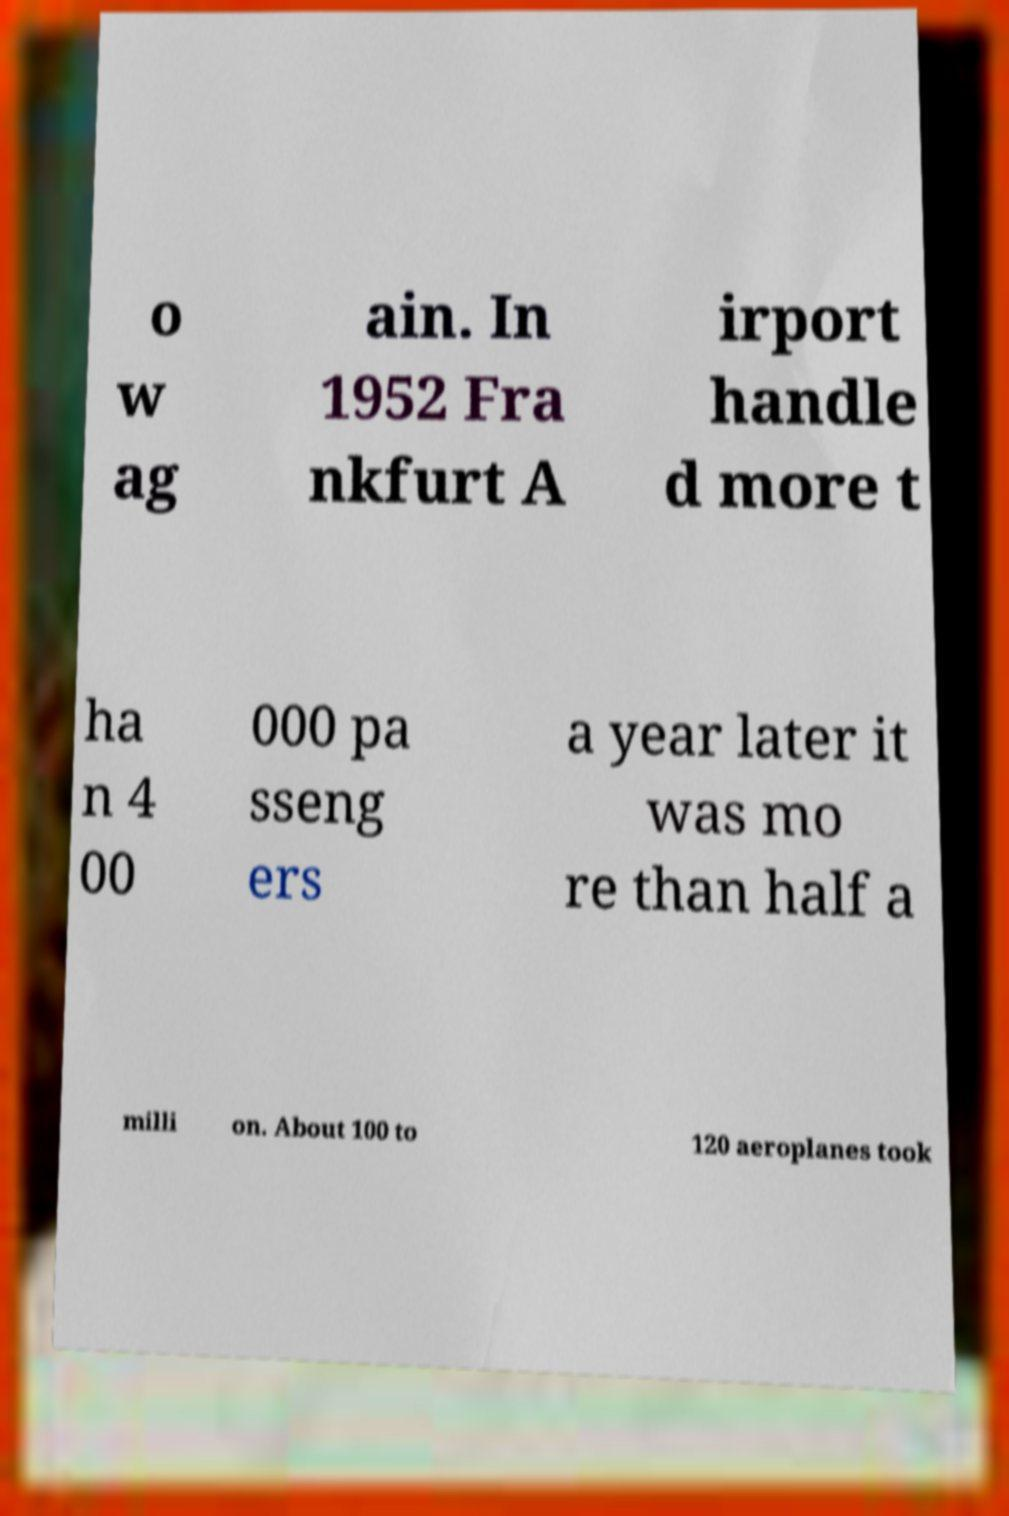I need the written content from this picture converted into text. Can you do that? o w ag ain. In 1952 Fra nkfurt A irport handle d more t ha n 4 00 000 pa sseng ers a year later it was mo re than half a milli on. About 100 to 120 aeroplanes took 